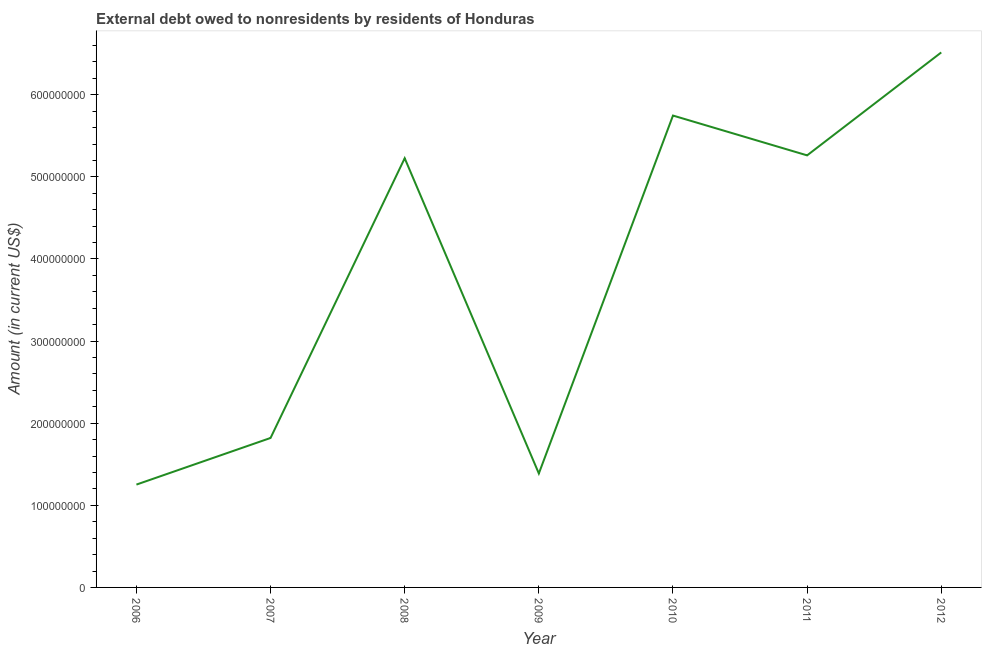What is the debt in 2007?
Keep it short and to the point. 1.82e+08. Across all years, what is the maximum debt?
Your response must be concise. 6.52e+08. Across all years, what is the minimum debt?
Offer a very short reply. 1.25e+08. In which year was the debt minimum?
Offer a terse response. 2006. What is the sum of the debt?
Offer a very short reply. 2.72e+09. What is the difference between the debt in 2009 and 2012?
Ensure brevity in your answer.  -5.13e+08. What is the average debt per year?
Keep it short and to the point. 3.89e+08. What is the median debt?
Ensure brevity in your answer.  5.23e+08. Do a majority of the years between 2011 and 2007 (inclusive) have debt greater than 540000000 US$?
Offer a very short reply. Yes. What is the ratio of the debt in 2010 to that in 2011?
Your answer should be very brief. 1.09. Is the debt in 2007 less than that in 2012?
Keep it short and to the point. Yes. What is the difference between the highest and the second highest debt?
Keep it short and to the point. 7.69e+07. What is the difference between the highest and the lowest debt?
Your answer should be very brief. 5.26e+08. In how many years, is the debt greater than the average debt taken over all years?
Provide a succinct answer. 4. How many years are there in the graph?
Your answer should be very brief. 7. Are the values on the major ticks of Y-axis written in scientific E-notation?
Provide a succinct answer. No. Does the graph contain grids?
Your answer should be compact. No. What is the title of the graph?
Give a very brief answer. External debt owed to nonresidents by residents of Honduras. What is the label or title of the X-axis?
Give a very brief answer. Year. What is the label or title of the Y-axis?
Give a very brief answer. Amount (in current US$). What is the Amount (in current US$) in 2006?
Give a very brief answer. 1.25e+08. What is the Amount (in current US$) in 2007?
Make the answer very short. 1.82e+08. What is the Amount (in current US$) of 2008?
Provide a short and direct response. 5.23e+08. What is the Amount (in current US$) in 2009?
Make the answer very short. 1.39e+08. What is the Amount (in current US$) in 2010?
Your answer should be compact. 5.75e+08. What is the Amount (in current US$) in 2011?
Ensure brevity in your answer.  5.26e+08. What is the Amount (in current US$) of 2012?
Provide a succinct answer. 6.52e+08. What is the difference between the Amount (in current US$) in 2006 and 2007?
Provide a succinct answer. -5.68e+07. What is the difference between the Amount (in current US$) in 2006 and 2008?
Provide a short and direct response. -3.97e+08. What is the difference between the Amount (in current US$) in 2006 and 2009?
Offer a terse response. -1.35e+07. What is the difference between the Amount (in current US$) in 2006 and 2010?
Make the answer very short. -4.49e+08. What is the difference between the Amount (in current US$) in 2006 and 2011?
Offer a very short reply. -4.01e+08. What is the difference between the Amount (in current US$) in 2006 and 2012?
Offer a terse response. -5.26e+08. What is the difference between the Amount (in current US$) in 2007 and 2008?
Offer a terse response. -3.41e+08. What is the difference between the Amount (in current US$) in 2007 and 2009?
Offer a very short reply. 4.33e+07. What is the difference between the Amount (in current US$) in 2007 and 2010?
Provide a short and direct response. -3.93e+08. What is the difference between the Amount (in current US$) in 2007 and 2011?
Provide a short and direct response. -3.44e+08. What is the difference between the Amount (in current US$) in 2007 and 2012?
Your answer should be compact. -4.70e+08. What is the difference between the Amount (in current US$) in 2008 and 2009?
Ensure brevity in your answer.  3.84e+08. What is the difference between the Amount (in current US$) in 2008 and 2010?
Keep it short and to the point. -5.20e+07. What is the difference between the Amount (in current US$) in 2008 and 2011?
Your answer should be very brief. -3.50e+06. What is the difference between the Amount (in current US$) in 2008 and 2012?
Give a very brief answer. -1.29e+08. What is the difference between the Amount (in current US$) in 2009 and 2010?
Your answer should be very brief. -4.36e+08. What is the difference between the Amount (in current US$) in 2009 and 2011?
Provide a succinct answer. -3.87e+08. What is the difference between the Amount (in current US$) in 2009 and 2012?
Your response must be concise. -5.13e+08. What is the difference between the Amount (in current US$) in 2010 and 2011?
Give a very brief answer. 4.85e+07. What is the difference between the Amount (in current US$) in 2010 and 2012?
Ensure brevity in your answer.  -7.69e+07. What is the difference between the Amount (in current US$) in 2011 and 2012?
Provide a succinct answer. -1.25e+08. What is the ratio of the Amount (in current US$) in 2006 to that in 2007?
Your answer should be compact. 0.69. What is the ratio of the Amount (in current US$) in 2006 to that in 2008?
Your answer should be very brief. 0.24. What is the ratio of the Amount (in current US$) in 2006 to that in 2009?
Make the answer very short. 0.9. What is the ratio of the Amount (in current US$) in 2006 to that in 2010?
Provide a succinct answer. 0.22. What is the ratio of the Amount (in current US$) in 2006 to that in 2011?
Provide a short and direct response. 0.24. What is the ratio of the Amount (in current US$) in 2006 to that in 2012?
Keep it short and to the point. 0.19. What is the ratio of the Amount (in current US$) in 2007 to that in 2008?
Provide a succinct answer. 0.35. What is the ratio of the Amount (in current US$) in 2007 to that in 2009?
Make the answer very short. 1.31. What is the ratio of the Amount (in current US$) in 2007 to that in 2010?
Provide a succinct answer. 0.32. What is the ratio of the Amount (in current US$) in 2007 to that in 2011?
Provide a succinct answer. 0.35. What is the ratio of the Amount (in current US$) in 2007 to that in 2012?
Provide a short and direct response. 0.28. What is the ratio of the Amount (in current US$) in 2008 to that in 2009?
Make the answer very short. 3.77. What is the ratio of the Amount (in current US$) in 2008 to that in 2010?
Keep it short and to the point. 0.91. What is the ratio of the Amount (in current US$) in 2008 to that in 2012?
Offer a very short reply. 0.8. What is the ratio of the Amount (in current US$) in 2009 to that in 2010?
Provide a short and direct response. 0.24. What is the ratio of the Amount (in current US$) in 2009 to that in 2011?
Your answer should be compact. 0.26. What is the ratio of the Amount (in current US$) in 2009 to that in 2012?
Provide a short and direct response. 0.21. What is the ratio of the Amount (in current US$) in 2010 to that in 2011?
Offer a terse response. 1.09. What is the ratio of the Amount (in current US$) in 2010 to that in 2012?
Your answer should be compact. 0.88. What is the ratio of the Amount (in current US$) in 2011 to that in 2012?
Offer a terse response. 0.81. 